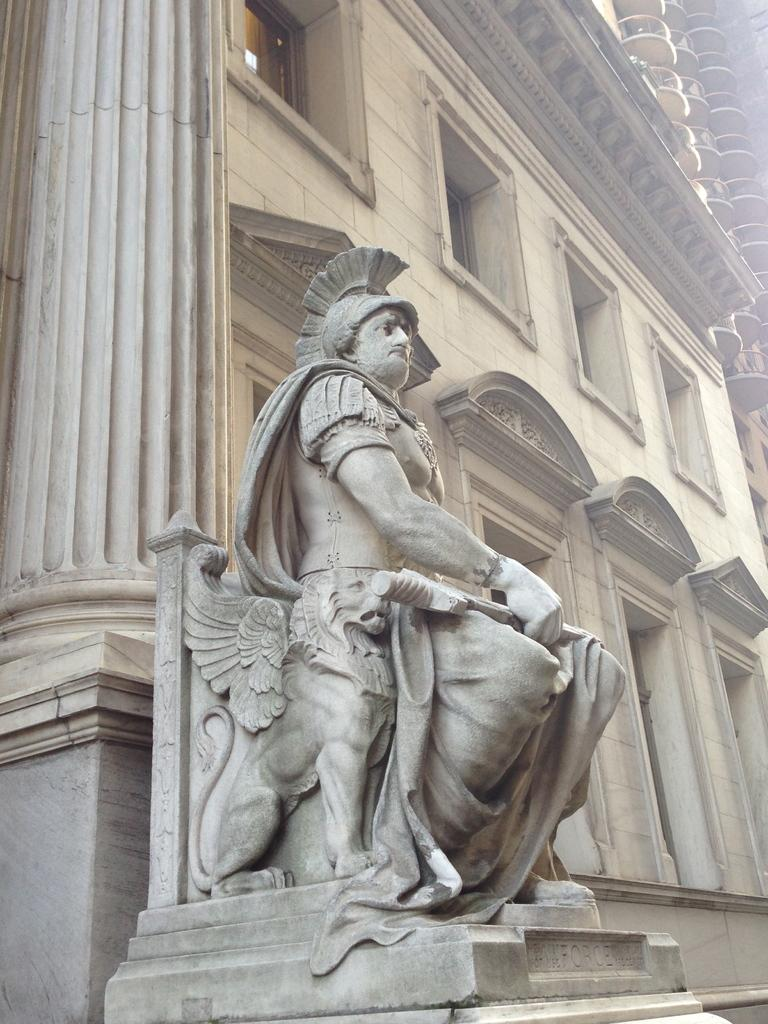What is the main subject in the center of the image? There is a sculpture in the center of the image. What can be seen in the background of the image? There is a building in the background of the image. Are there any architectural elements visible in the image? Yes, there is a pillar visible in the image. Is the sculpture feeling hot in the image? The sculpture is an inanimate object and cannot feel heat or any other sensations. 